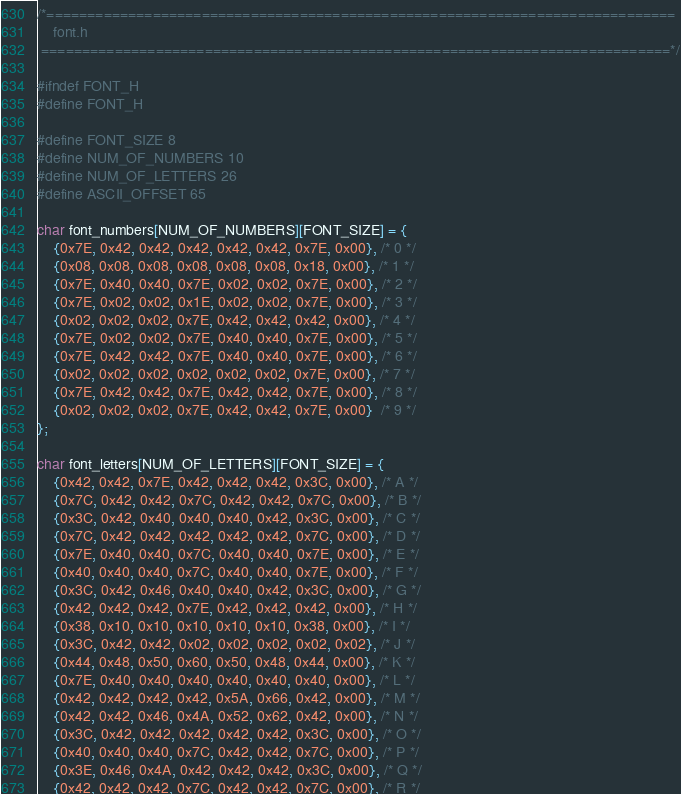<code> <loc_0><loc_0><loc_500><loc_500><_C_>/*=============================================================================
    font.h
 =============================================================================*/

#ifndef FONT_H
#define FONT_H

#define FONT_SIZE 8
#define NUM_OF_NUMBERS 10
#define NUM_OF_LETTERS 26
#define ASCII_OFFSET 65

char font_numbers[NUM_OF_NUMBERS][FONT_SIZE] = {
    {0x7E, 0x42, 0x42, 0x42, 0x42, 0x42, 0x7E, 0x00}, /* 0 */
    {0x08, 0x08, 0x08, 0x08, 0x08, 0x08, 0x18, 0x00}, /* 1 */
    {0x7E, 0x40, 0x40, 0x7E, 0x02, 0x02, 0x7E, 0x00}, /* 2 */
    {0x7E, 0x02, 0x02, 0x1E, 0x02, 0x02, 0x7E, 0x00}, /* 3 */
    {0x02, 0x02, 0x02, 0x7E, 0x42, 0x42, 0x42, 0x00}, /* 4 */
    {0x7E, 0x02, 0x02, 0x7E, 0x40, 0x40, 0x7E, 0x00}, /* 5 */
    {0x7E, 0x42, 0x42, 0x7E, 0x40, 0x40, 0x7E, 0x00}, /* 6 */
    {0x02, 0x02, 0x02, 0x02, 0x02, 0x02, 0x7E, 0x00}, /* 7 */
    {0x7E, 0x42, 0x42, 0x7E, 0x42, 0x42, 0x7E, 0x00}, /* 8 */
    {0x02, 0x02, 0x02, 0x7E, 0x42, 0x42, 0x7E, 0x00}  /* 9 */
};

char font_letters[NUM_OF_LETTERS][FONT_SIZE] = {
    {0x42, 0x42, 0x7E, 0x42, 0x42, 0x42, 0x3C, 0x00}, /* A */
    {0x7C, 0x42, 0x42, 0x7C, 0x42, 0x42, 0x7C, 0x00}, /* B */
    {0x3C, 0x42, 0x40, 0x40, 0x40, 0x42, 0x3C, 0x00}, /* C */
    {0x7C, 0x42, 0x42, 0x42, 0x42, 0x42, 0x7C, 0x00}, /* D */
    {0x7E, 0x40, 0x40, 0x7C, 0x40, 0x40, 0x7E, 0x00}, /* E */
    {0x40, 0x40, 0x40, 0x7C, 0x40, 0x40, 0x7E, 0x00}, /* F */
    {0x3C, 0x42, 0x46, 0x40, 0x40, 0x42, 0x3C, 0x00}, /* G */
    {0x42, 0x42, 0x42, 0x7E, 0x42, 0x42, 0x42, 0x00}, /* H */
    {0x38, 0x10, 0x10, 0x10, 0x10, 0x10, 0x38, 0x00}, /* I */
    {0x3C, 0x42, 0x42, 0x02, 0x02, 0x02, 0x02, 0x02}, /* J */
    {0x44, 0x48, 0x50, 0x60, 0x50, 0x48, 0x44, 0x00}, /* K */
    {0x7E, 0x40, 0x40, 0x40, 0x40, 0x40, 0x40, 0x00}, /* L */
    {0x42, 0x42, 0x42, 0x42, 0x5A, 0x66, 0x42, 0x00}, /* M */
    {0x42, 0x42, 0x46, 0x4A, 0x52, 0x62, 0x42, 0x00}, /* N */
    {0x3C, 0x42, 0x42, 0x42, 0x42, 0x42, 0x3C, 0x00}, /* O */
    {0x40, 0x40, 0x40, 0x7C, 0x42, 0x42, 0x7C, 0x00}, /* P */
    {0x3E, 0x46, 0x4A, 0x42, 0x42, 0x42, 0x3C, 0x00}, /* Q */
    {0x42, 0x42, 0x42, 0x7C, 0x42, 0x42, 0x7C, 0x00}, /* R */</code> 